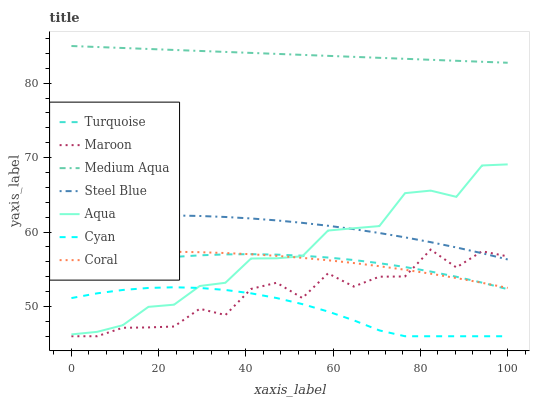Does Cyan have the minimum area under the curve?
Answer yes or no. Yes. Does Medium Aqua have the maximum area under the curve?
Answer yes or no. Yes. Does Coral have the minimum area under the curve?
Answer yes or no. No. Does Coral have the maximum area under the curve?
Answer yes or no. No. Is Medium Aqua the smoothest?
Answer yes or no. Yes. Is Maroon the roughest?
Answer yes or no. Yes. Is Coral the smoothest?
Answer yes or no. No. Is Coral the roughest?
Answer yes or no. No. Does Maroon have the lowest value?
Answer yes or no. Yes. Does Coral have the lowest value?
Answer yes or no. No. Does Medium Aqua have the highest value?
Answer yes or no. Yes. Does Coral have the highest value?
Answer yes or no. No. Is Cyan less than Steel Blue?
Answer yes or no. Yes. Is Aqua greater than Maroon?
Answer yes or no. Yes. Does Coral intersect Maroon?
Answer yes or no. Yes. Is Coral less than Maroon?
Answer yes or no. No. Is Coral greater than Maroon?
Answer yes or no. No. Does Cyan intersect Steel Blue?
Answer yes or no. No. 